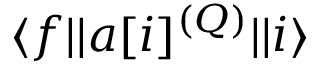<formula> <loc_0><loc_0><loc_500><loc_500>{ \langle f | | } a [ i ] ^ { ( Q ) } { | | i \rangle }</formula> 